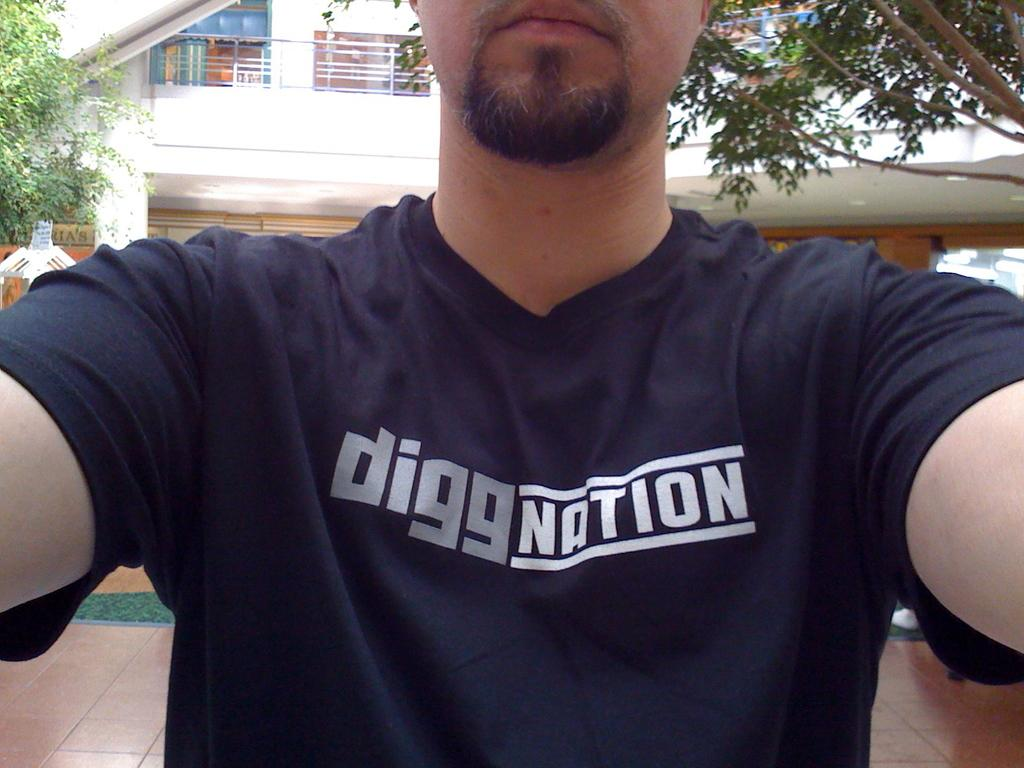<image>
Provide a brief description of the given image. the word digg is on a shirt that is black 